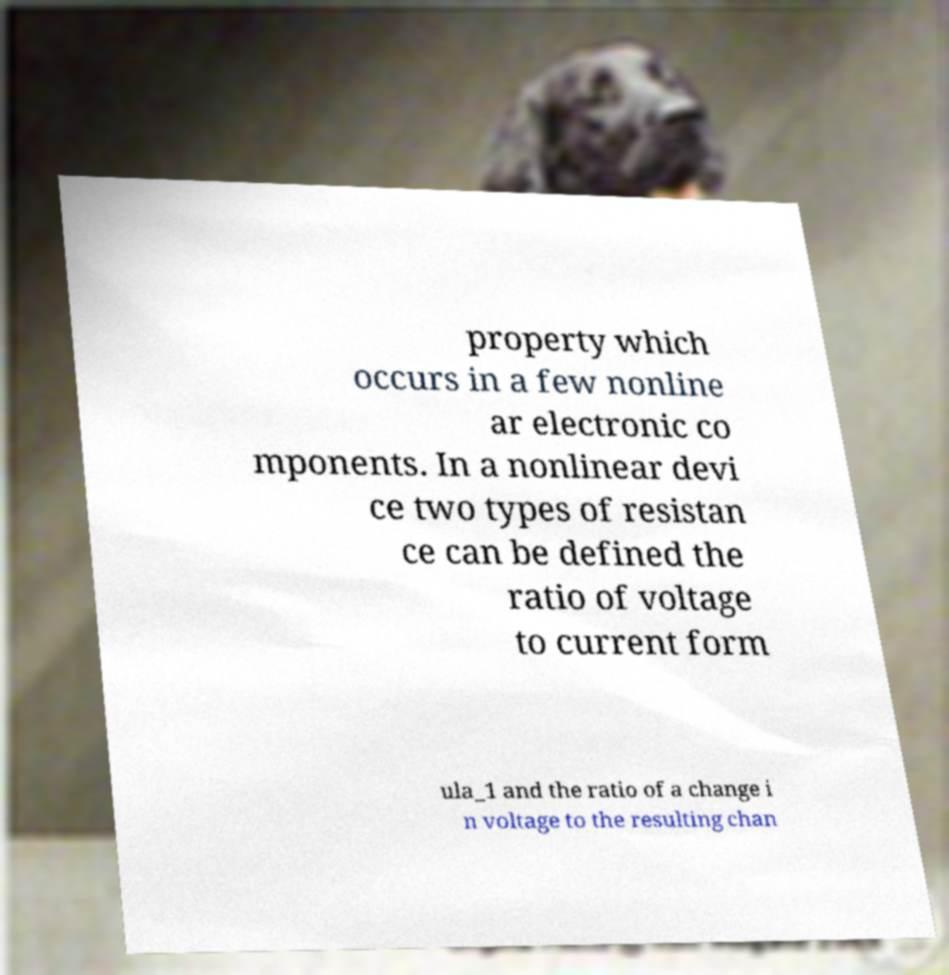Could you assist in decoding the text presented in this image and type it out clearly? property which occurs in a few nonline ar electronic co mponents. In a nonlinear devi ce two types of resistan ce can be defined the ratio of voltage to current form ula_1 and the ratio of a change i n voltage to the resulting chan 